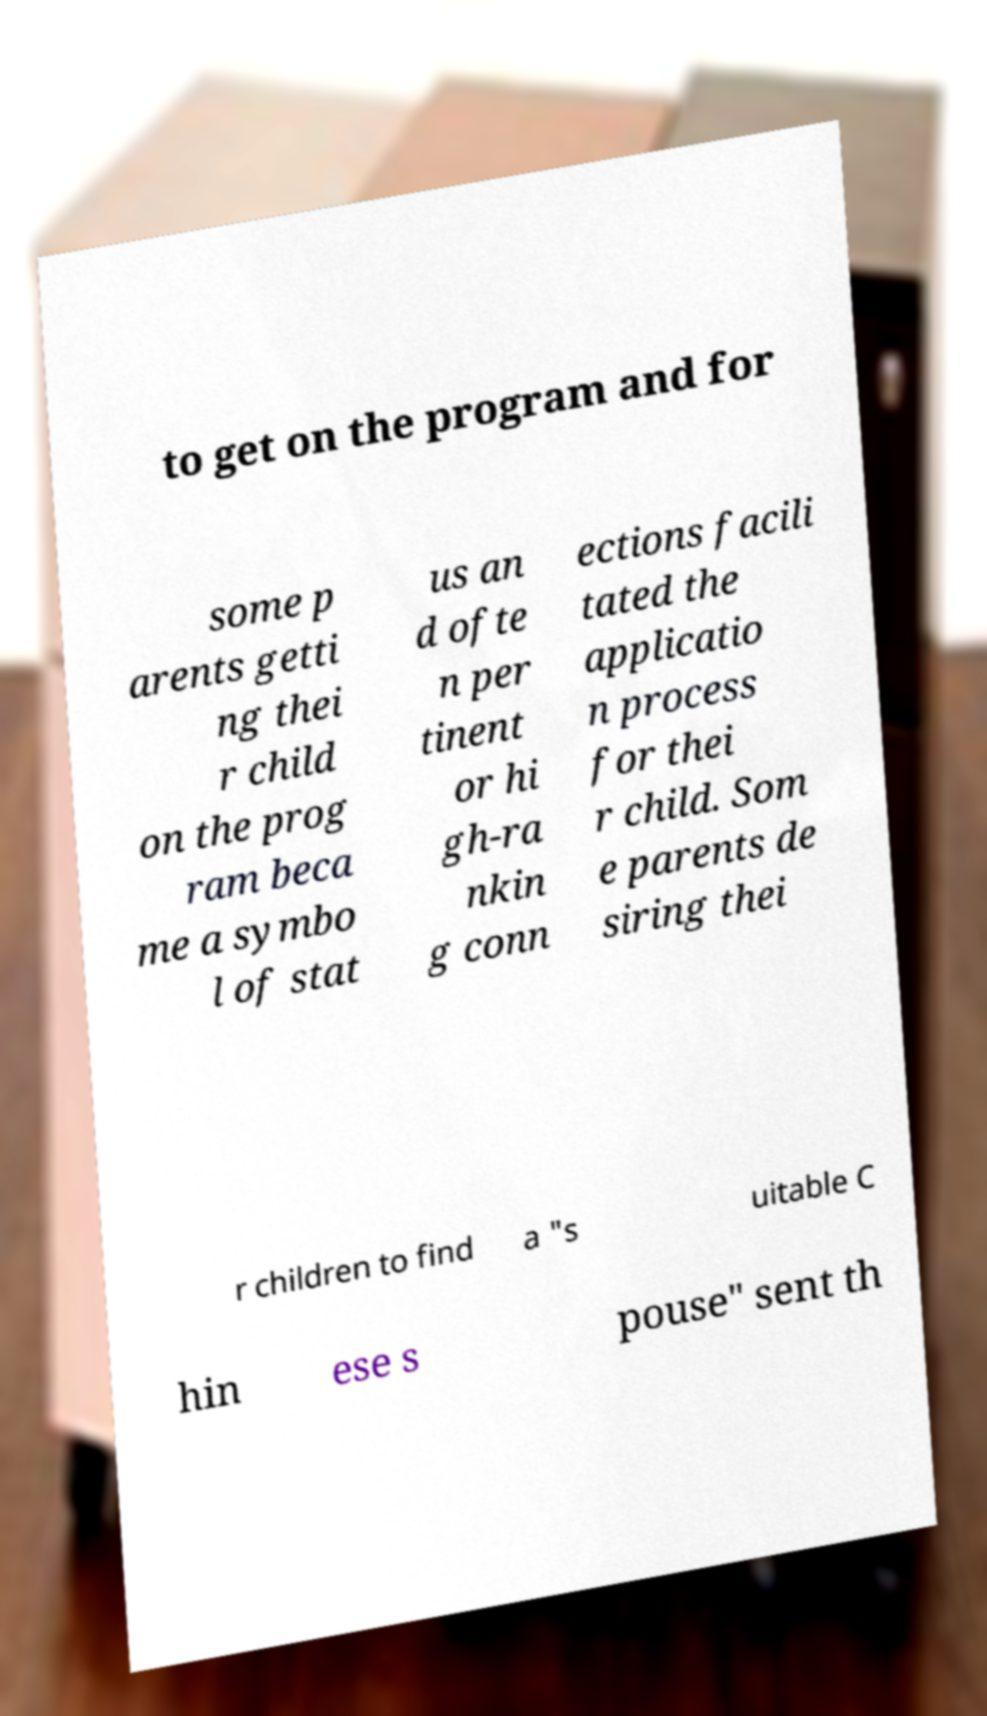I need the written content from this picture converted into text. Can you do that? to get on the program and for some p arents getti ng thei r child on the prog ram beca me a symbo l of stat us an d ofte n per tinent or hi gh-ra nkin g conn ections facili tated the applicatio n process for thei r child. Som e parents de siring thei r children to find a "s uitable C hin ese s pouse" sent th 